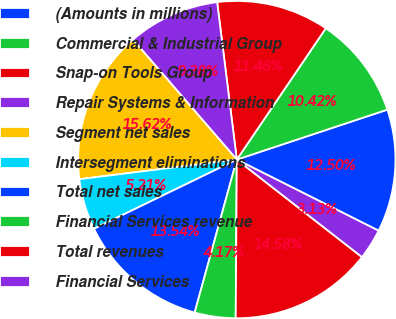<chart> <loc_0><loc_0><loc_500><loc_500><pie_chart><fcel>(Amounts in millions)<fcel>Commercial & Industrial Group<fcel>Snap-on Tools Group<fcel>Repair Systems & Information<fcel>Segment net sales<fcel>Intersegment eliminations<fcel>Total net sales<fcel>Financial Services revenue<fcel>Total revenues<fcel>Financial Services<nl><fcel>12.5%<fcel>10.42%<fcel>11.46%<fcel>9.38%<fcel>15.62%<fcel>5.21%<fcel>13.54%<fcel>4.17%<fcel>14.58%<fcel>3.13%<nl></chart> 